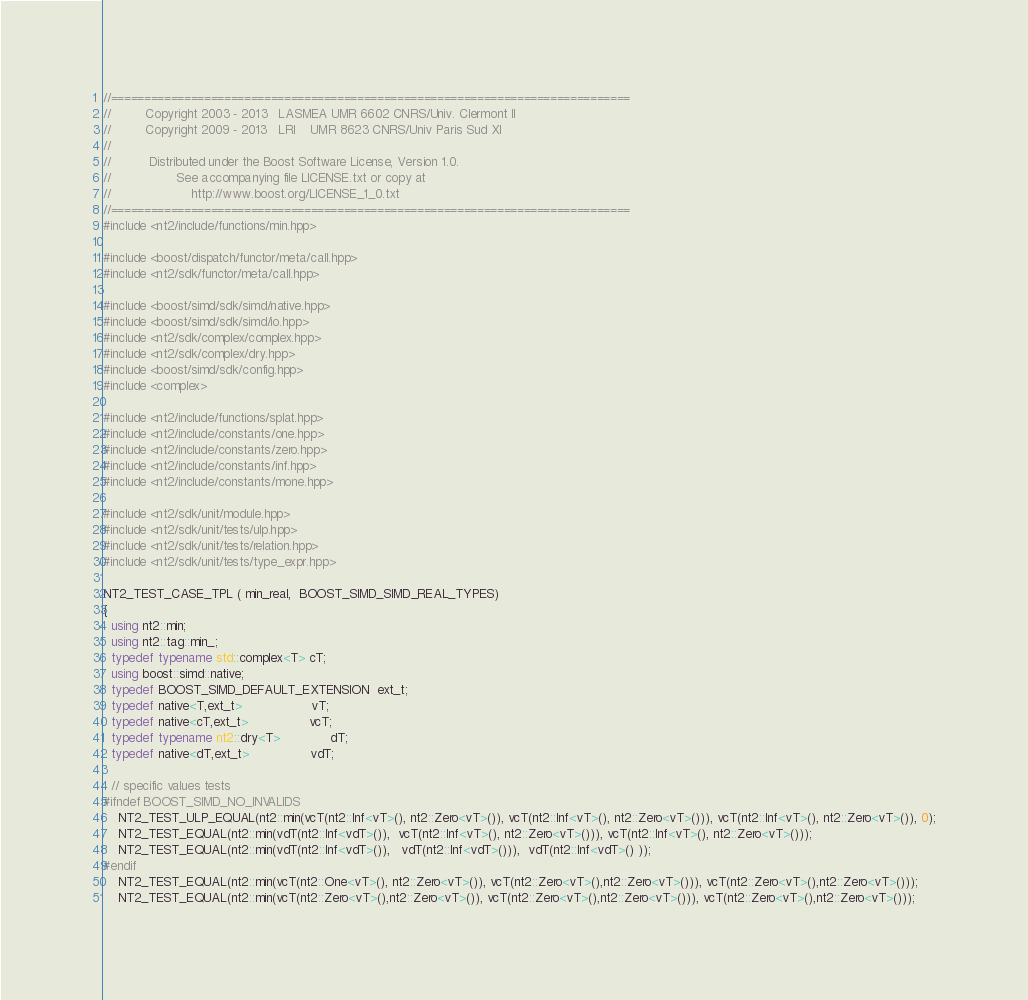<code> <loc_0><loc_0><loc_500><loc_500><_C++_>//==============================================================================
//         Copyright 2003 - 2013   LASMEA UMR 6602 CNRS/Univ. Clermont II
//         Copyright 2009 - 2013   LRI    UMR 8623 CNRS/Univ Paris Sud XI
//
//          Distributed under the Boost Software License, Version 1.0.
//                 See accompanying file LICENSE.txt or copy at
//                     http://www.boost.org/LICENSE_1_0.txt
//==============================================================================
#include <nt2/include/functions/min.hpp>

#include <boost/dispatch/functor/meta/call.hpp>
#include <nt2/sdk/functor/meta/call.hpp>

#include <boost/simd/sdk/simd/native.hpp>
#include <boost/simd/sdk/simd/io.hpp>
#include <nt2/sdk/complex/complex.hpp>
#include <nt2/sdk/complex/dry.hpp>
#include <boost/simd/sdk/config.hpp>
#include <complex>

#include <nt2/include/functions/splat.hpp>
#include <nt2/include/constants/one.hpp>
#include <nt2/include/constants/zero.hpp>
#include <nt2/include/constants/inf.hpp>
#include <nt2/include/constants/mone.hpp>

#include <nt2/sdk/unit/module.hpp>
#include <nt2/sdk/unit/tests/ulp.hpp>
#include <nt2/sdk/unit/tests/relation.hpp>
#include <nt2/sdk/unit/tests/type_expr.hpp>

NT2_TEST_CASE_TPL ( min_real,  BOOST_SIMD_SIMD_REAL_TYPES)
{
  using nt2::min;
  using nt2::tag::min_;
  typedef typename std::complex<T> cT;
  using boost::simd::native;
  typedef BOOST_SIMD_DEFAULT_EXTENSION  ext_t;
  typedef native<T,ext_t>                  vT;
  typedef native<cT,ext_t>                vcT;
  typedef typename nt2::dry<T>             dT;
  typedef native<dT,ext_t>                vdT;

  // specific values tests
#ifndef BOOST_SIMD_NO_INVALIDS
    NT2_TEST_ULP_EQUAL(nt2::min(vcT(nt2::Inf<vT>(), nt2::Zero<vT>()), vcT(nt2::Inf<vT>(), nt2::Zero<vT>())), vcT(nt2::Inf<vT>(), nt2::Zero<vT>()), 0);
    NT2_TEST_EQUAL(nt2::min(vdT(nt2::Inf<vdT>()),  vcT(nt2::Inf<vT>(), nt2::Zero<vT>())), vcT(nt2::Inf<vT>(), nt2::Zero<vT>()));
    NT2_TEST_EQUAL(nt2::min(vdT(nt2::Inf<vdT>()),   vdT(nt2::Inf<vdT>())),  vdT(nt2::Inf<vdT>() ));
#endif
    NT2_TEST_EQUAL(nt2::min(vcT(nt2::One<vT>(), nt2::Zero<vT>()), vcT(nt2::Zero<vT>(),nt2::Zero<vT>())), vcT(nt2::Zero<vT>(),nt2::Zero<vT>()));
    NT2_TEST_EQUAL(nt2::min(vcT(nt2::Zero<vT>(),nt2::Zero<vT>()), vcT(nt2::Zero<vT>(),nt2::Zero<vT>())), vcT(nt2::Zero<vT>(),nt2::Zero<vT>()));</code> 